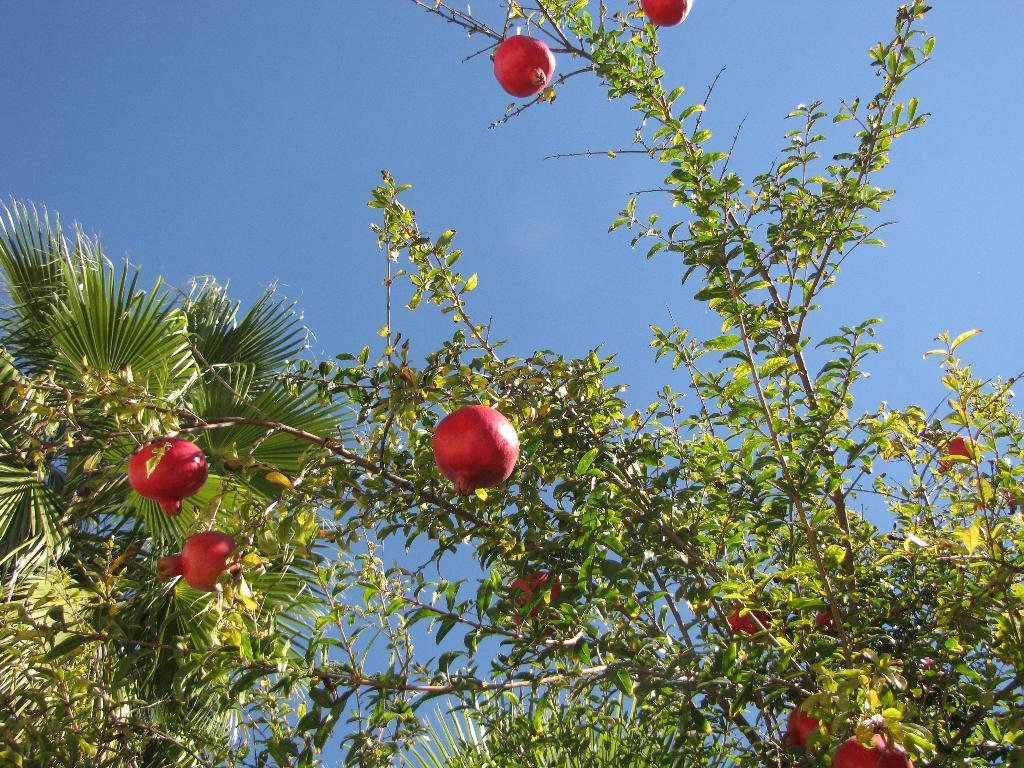What type of fruit can be seen on the plant in the image? There are pomegranates in red color on a plant in the image. What kind of tree is on the left side of the image? There is a palm tree on the left side of the image. What color is the sky in the image? The sky is blue in color. Is there any visible pollution in the image? There is no visible pollution in the image. Can you see any steam coming from the pomegranates? There is no steam coming from the pomegranates in the image. 